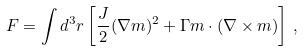<formula> <loc_0><loc_0><loc_500><loc_500>F = \int d ^ { 3 } r \left [ \frac { J } { 2 } ( \nabla m ) ^ { 2 } + \Gamma m \cdot ( \nabla \times m ) \right ] \, ,</formula> 